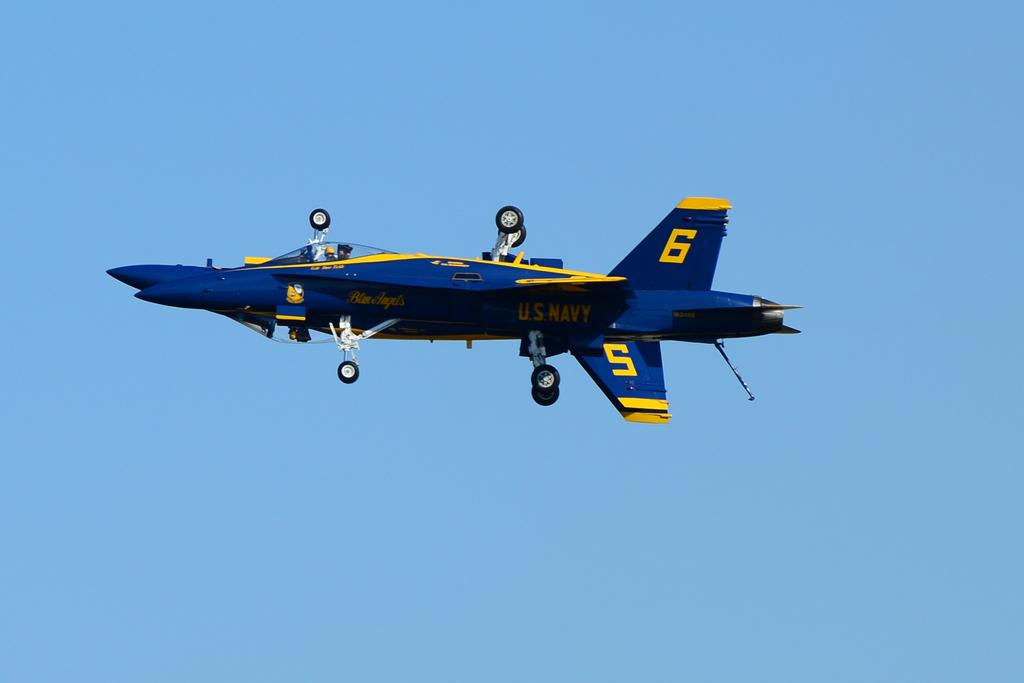Which branch of the military does the aircraft belong to?
Your response must be concise. Navy. What is the number on the upside down plane?
Offer a very short reply. 5. 